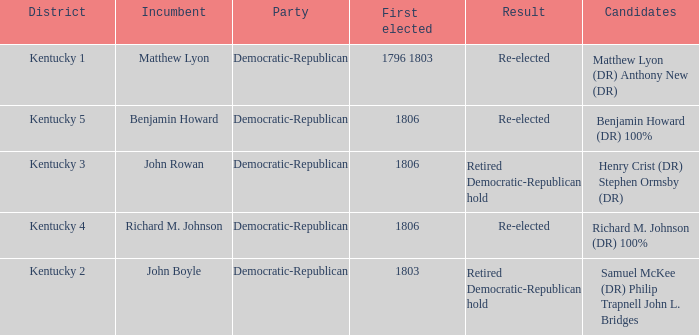Name the first elected for kentucky 1 1796 1803. 